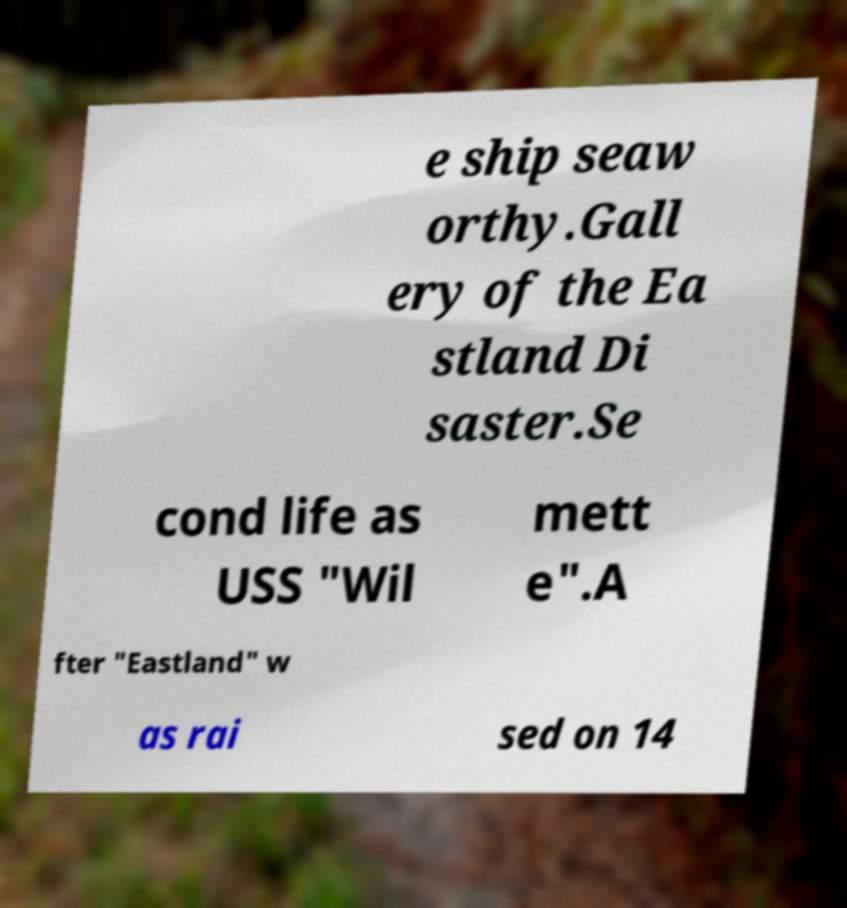For documentation purposes, I need the text within this image transcribed. Could you provide that? e ship seaw orthy.Gall ery of the Ea stland Di saster.Se cond life as USS "Wil mett e".A fter "Eastland" w as rai sed on 14 